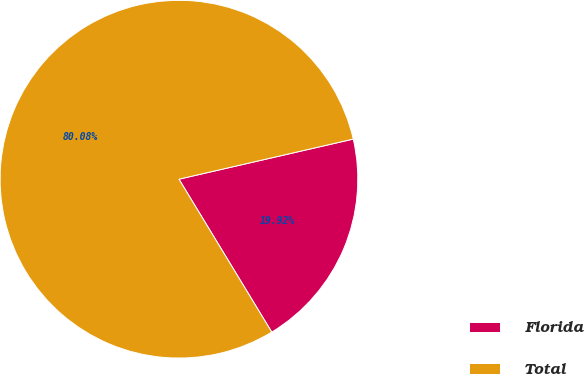<chart> <loc_0><loc_0><loc_500><loc_500><pie_chart><fcel>Florida<fcel>Total<nl><fcel>19.92%<fcel>80.08%<nl></chart> 